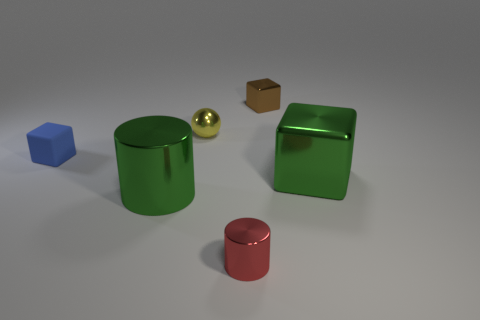There is a cylinder in front of the green metallic object in front of the green metallic cube; what is it made of?
Give a very brief answer. Metal. There is a tiny object that is both behind the matte cube and to the left of the small brown shiny object; what material is it?
Provide a succinct answer. Metal. Are there any other big objects that have the same shape as the brown thing?
Make the answer very short. Yes. There is a shiny block in front of the tiny yellow metallic object; is there a tiny thing that is on the left side of it?
Make the answer very short. Yes. What number of tiny balls are made of the same material as the brown cube?
Your answer should be very brief. 1. Is there a metal cylinder?
Your answer should be compact. Yes. What number of shiny cylinders are the same color as the big cube?
Your answer should be very brief. 1. Is the brown object made of the same material as the big object that is in front of the big green cube?
Make the answer very short. Yes. Is the number of small yellow spheres that are left of the yellow thing greater than the number of tiny cyan rubber cylinders?
Make the answer very short. No. Are there any other things that have the same size as the brown cube?
Give a very brief answer. Yes. 